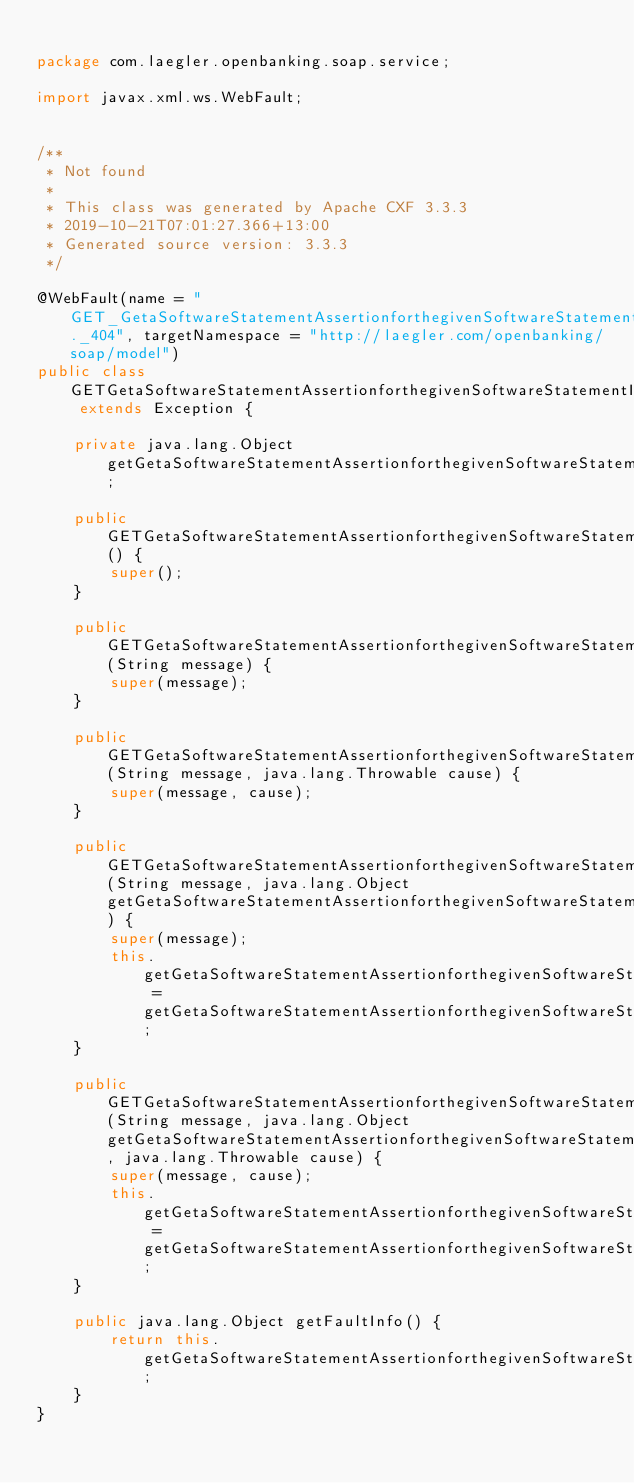<code> <loc_0><loc_0><loc_500><loc_500><_Java_>
package com.laegler.openbanking.soap.service;

import javax.xml.ws.WebFault;


/**
 * Not found
 *
 * This class was generated by Apache CXF 3.3.3
 * 2019-10-21T07:01:27.366+13:00
 * Generated source version: 3.3.3
 */

@WebFault(name = "GET_GetaSoftwareStatementAssertionforthegivenSoftwareStatementID._404", targetNamespace = "http://laegler.com/openbanking/soap/model")
public class GETGetaSoftwareStatementAssertionforthegivenSoftwareStatementID404 extends Exception {

    private java.lang.Object getGetaSoftwareStatementAssertionforthegivenSoftwareStatementID404;

    public GETGetaSoftwareStatementAssertionforthegivenSoftwareStatementID404() {
        super();
    }

    public GETGetaSoftwareStatementAssertionforthegivenSoftwareStatementID404(String message) {
        super(message);
    }

    public GETGetaSoftwareStatementAssertionforthegivenSoftwareStatementID404(String message, java.lang.Throwable cause) {
        super(message, cause);
    }

    public GETGetaSoftwareStatementAssertionforthegivenSoftwareStatementID404(String message, java.lang.Object getGetaSoftwareStatementAssertionforthegivenSoftwareStatementID404) {
        super(message);
        this.getGetaSoftwareStatementAssertionforthegivenSoftwareStatementID404 = getGetaSoftwareStatementAssertionforthegivenSoftwareStatementID404;
    }

    public GETGetaSoftwareStatementAssertionforthegivenSoftwareStatementID404(String message, java.lang.Object getGetaSoftwareStatementAssertionforthegivenSoftwareStatementID404, java.lang.Throwable cause) {
        super(message, cause);
        this.getGetaSoftwareStatementAssertionforthegivenSoftwareStatementID404 = getGetaSoftwareStatementAssertionforthegivenSoftwareStatementID404;
    }

    public java.lang.Object getFaultInfo() {
        return this.getGetaSoftwareStatementAssertionforthegivenSoftwareStatementID404;
    }
}
</code> 